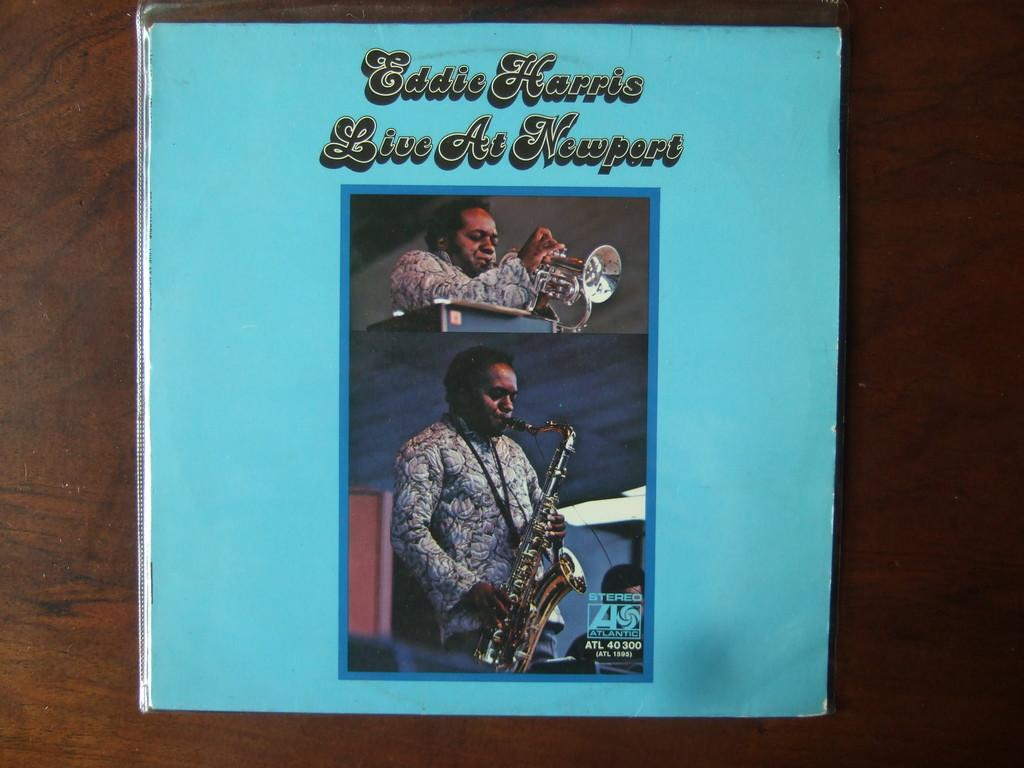<image>
Give a short and clear explanation of the subsequent image. A blue poster displays Eddie Harris Live at Newport 